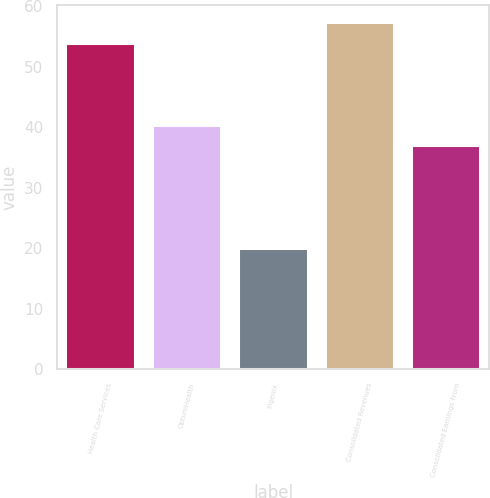<chart> <loc_0><loc_0><loc_500><loc_500><bar_chart><fcel>Health Care Services<fcel>OptumHealth<fcel>Ingenix<fcel>Consolidated Revenues<fcel>Consolidated Earnings From<nl><fcel>54<fcel>40.4<fcel>20<fcel>57.4<fcel>37<nl></chart> 